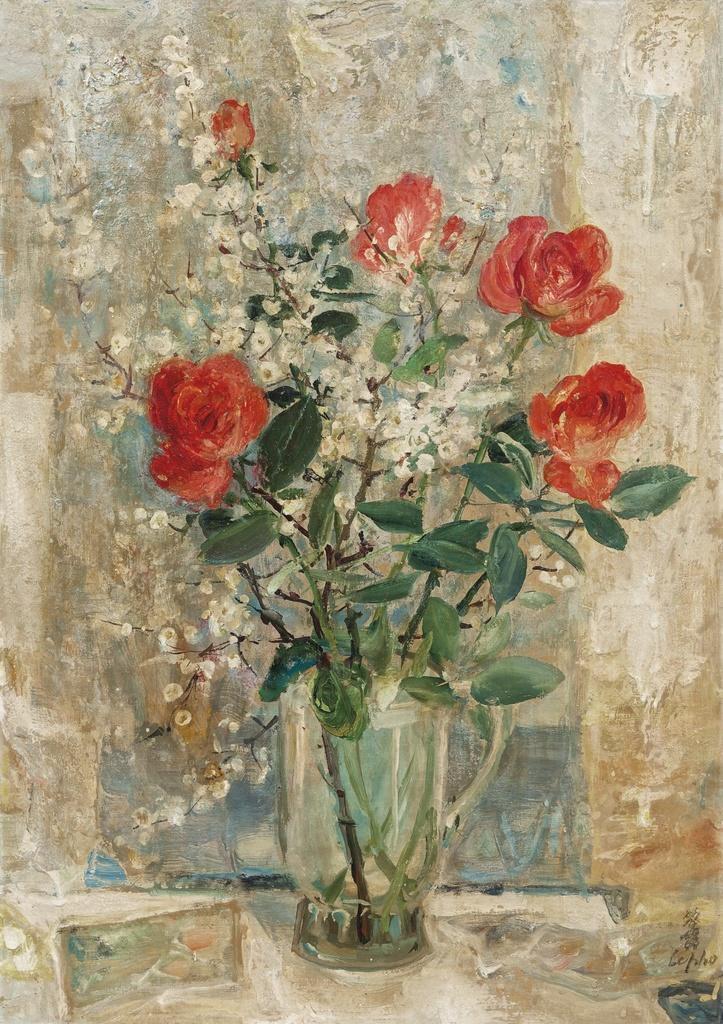What is the main subject of the image? The image contains a painting. What is the painting depicting? The painting depicts a flower vase. What type of fuel is being used to power the flower vase in the painting? There is no fuel or power source mentioned in the painting, as it depicts a flower vase. How is the pollution level in the painting? The painting does not depict any pollution or environmental factors; it only shows a flower vase. 